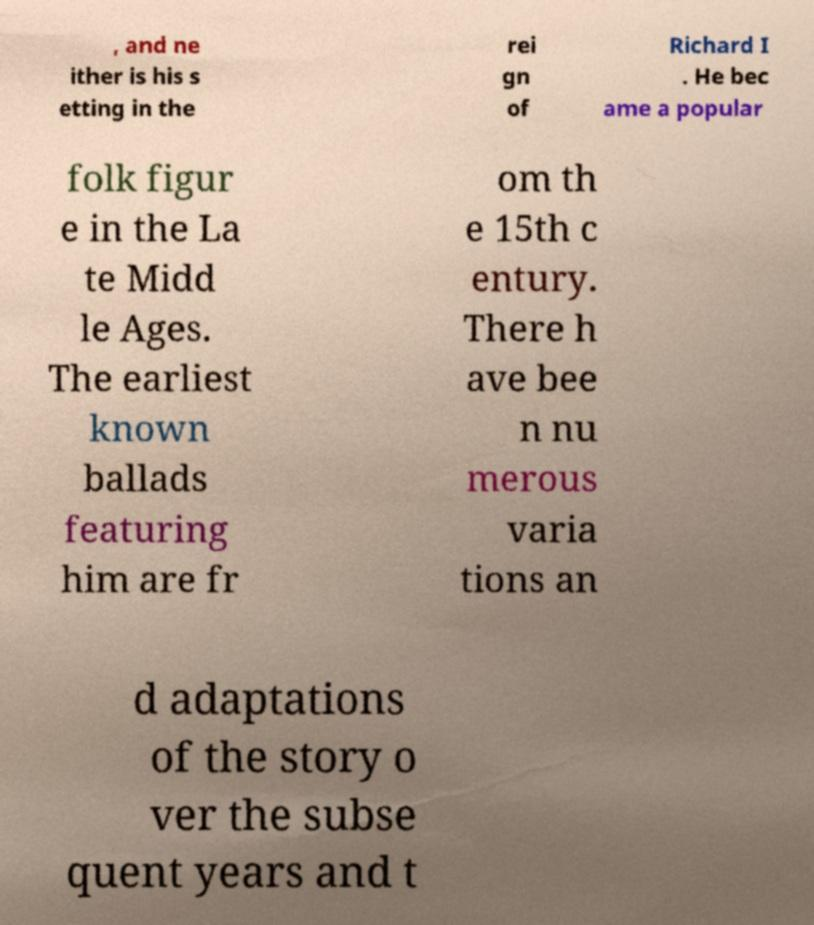Please identify and transcribe the text found in this image. , and ne ither is his s etting in the rei gn of Richard I . He bec ame a popular folk figur e in the La te Midd le Ages. The earliest known ballads featuring him are fr om th e 15th c entury. There h ave bee n nu merous varia tions an d adaptations of the story o ver the subse quent years and t 